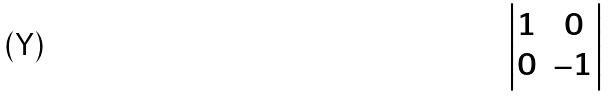Convert formula to latex. <formula><loc_0><loc_0><loc_500><loc_500>\begin{vmatrix} 1 & 0 \\ 0 & - 1 \\ \end{vmatrix}</formula> 